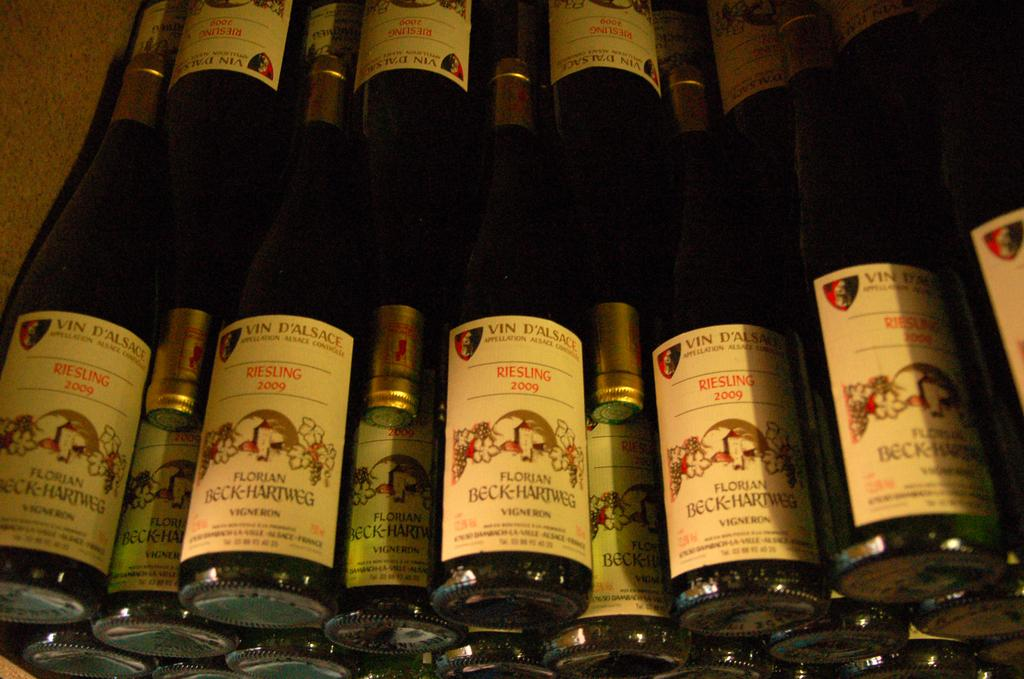Provide a one-sentence caption for the provided image. Bottles of alcohol with a label that says "Florian Beck-Hartweg". 